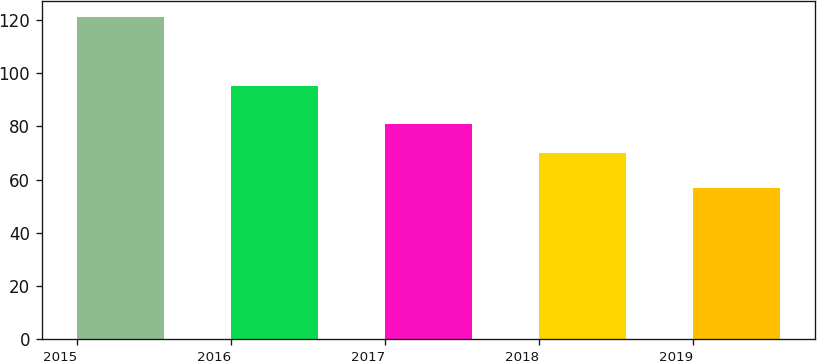Convert chart to OTSL. <chart><loc_0><loc_0><loc_500><loc_500><bar_chart><fcel>2015<fcel>2016<fcel>2017<fcel>2018<fcel>2019<nl><fcel>121<fcel>95<fcel>81<fcel>70<fcel>57<nl></chart> 